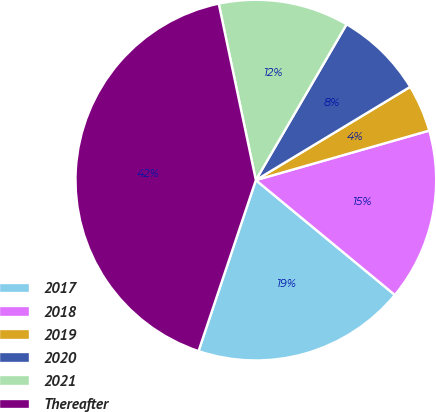Convert chart to OTSL. <chart><loc_0><loc_0><loc_500><loc_500><pie_chart><fcel>2017<fcel>2018<fcel>2019<fcel>2020<fcel>2021<fcel>Thereafter<nl><fcel>19.16%<fcel>15.42%<fcel>4.22%<fcel>7.96%<fcel>11.69%<fcel>41.55%<nl></chart> 